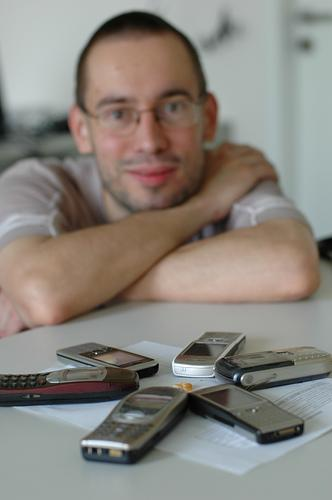Describe the sentiment conveyed by the image. A sense of curiosity and interest as the man is surrounded by various cell phones and observing the viewer. What is the man's relationship with the objects on the table? The man is resting his arms on the table while looking at the camera, surrounded by six cell phones. Provide a detailed description of the man's facial features. The man has dark brown hair, brown eyes, a thin beard, and is wearing glasses. What is the prominent object that includes the color red in the image? A red and black cell phone on the table. How many cell phones can be seen on the table? Six cell phones of various colors and styles. Count and identify the different types of objects in the image. Six cell phones, one piece of paper, eyeglasses on the man's face, the man himself, and a white table. Analyze the interaction between the man and the objects on the table. The man is resting his arms on the table and observing the six cell phones closely while maintaining eye contact with the viewer. Is there anything between the phones and the table? Yes, there is a paper under the phones. Identify the black briefcase next to the man's left leg. No, it's not mentioned in the image. Which cell phone is silver? There are two silver cell phones. What type of glasses is the man wearing? Eyeglasses. Is the man's eye open or closed? Open. Write a caption for the man in the image. Man looking at the camera, wearing glasses, with short dark hair and a thin beard. What are the different types of cell phones mentioned in the image? Silver cell phone, cordless flip phone, silver and black cell phone, red and black cell phone, candy bar style phone, and mobile hand set. Describe the man's appearance. The man has dark, short, straight hair, is wearing glasses, and has a thin beard. List the objects found on the table. Cell phones, a piece of paper, and a white table. What's on the man's left ear? An ear. How many cell phones are on the table? Six. Describe the position of the paper in relation to the phones. The paper is under the phones. Identify the colors of the cell phones. Silver, red and black, and black and red. Create a poem describing the scene in the image. A man with glasses fair, six cell phones scattered there, Where is the man looking? At the camera. What is the background of the photo like? Blurry. What is the man doing in the image? Resting his arms on the table and looking at the camera. What facial feature can be seen on the man's face? Glasses. Choose the correct description of the man's hair from the following options: a) long and curly, b) short and straight, c) medium and wavy. b) short and straight. 